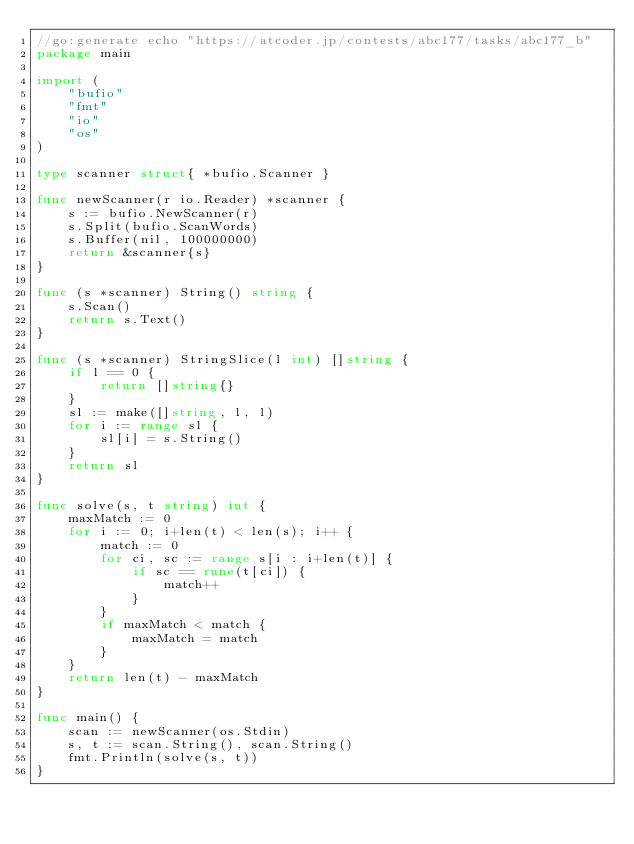Convert code to text. <code><loc_0><loc_0><loc_500><loc_500><_Go_>//go:generate echo "https://atcoder.jp/contests/abc177/tasks/abc177_b"
package main

import (
	"bufio"
	"fmt"
	"io"
	"os"
)

type scanner struct{ *bufio.Scanner }

func newScanner(r io.Reader) *scanner {
	s := bufio.NewScanner(r)
	s.Split(bufio.ScanWords)
	s.Buffer(nil, 100000000)
	return &scanner{s}
}

func (s *scanner) String() string {
	s.Scan()
	return s.Text()
}

func (s *scanner) StringSlice(l int) []string {
	if l == 0 {
		return []string{}
	}
	sl := make([]string, l, l)
	for i := range sl {
		sl[i] = s.String()
	}
	return sl
}

func solve(s, t string) int {
	maxMatch := 0
	for i := 0; i+len(t) < len(s); i++ {
		match := 0
		for ci, sc := range s[i : i+len(t)] {
			if sc == rune(t[ci]) {
				match++
			}
		}
		if maxMatch < match {
			maxMatch = match
		}
	}
	return len(t) - maxMatch
}

func main() {
	scan := newScanner(os.Stdin)
	s, t := scan.String(), scan.String()
	fmt.Println(solve(s, t))
}
</code> 